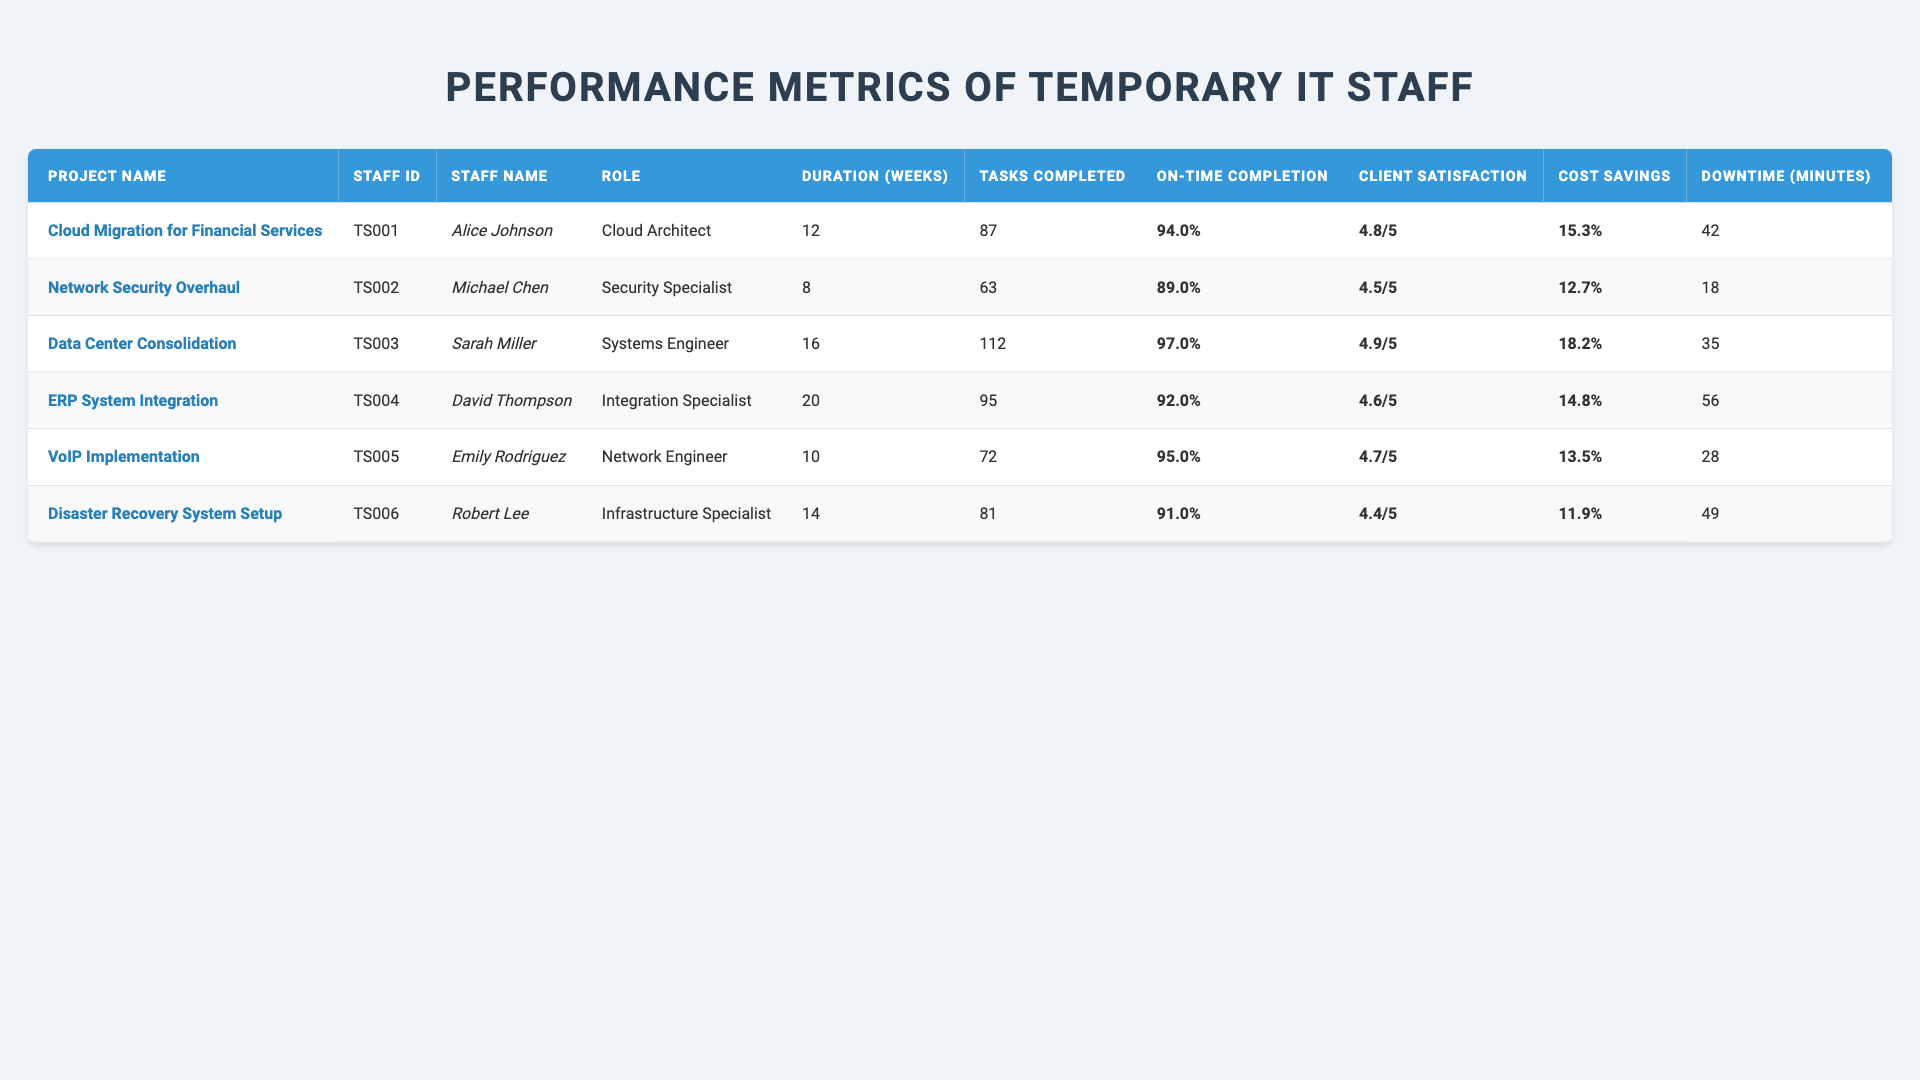What is the project duration for the "Data Center Consolidation"? The table shows that the project duration for "Data Center Consolidation" is 16 weeks.
Answer: 16 weeks Who completed the most tasks? The table indicates that Sarah Miller from the project "Data Center Consolidation" completed the most tasks with a total of 112.
Answer: Sarah Miller What is the on-time completion rate of the "VoIP Implementation"? The table specifies that the on-time completion rate for the "VoIP Implementation" is 95%.
Answer: 95% Which staff member had the highest client satisfaction score? According to the table, Sarah Miller scored the highest client satisfaction at 4.9.
Answer: Sarah Miller How many minutes of downtime did Robert Lee's project incur? The table states that Robert Lee’s project, "Disaster Recovery System Setup," incurred 49 minutes of downtime.
Answer: 49 minutes What is the average cost savings percentage of all projects? The cost savings percentages are: 15.3, 12.7, 18.2, 14.8, 13.5, and 11.9. The sum of these values is 86.4. There are 6 projects, so the average is 86.4/6 = 14.4.
Answer: 14.4% Is there any project where the client satisfaction score was below 4.5? By examining the table, the client satisfaction score for "Disaster Recovery System Setup" is 4.4, which is below 4.5.
Answer: Yes What is the total number of tasks completed by all temporary staff? The total tasks completed are: 87, 63, 112, 95, 72, and 81. Adding these gives 510 (87+63+112+95+72+81=510).
Answer: 510 tasks What is the difference in on-time completion rate between the "Network Security Overhaul" and the "Cloud Migration for Financial Services"? The on-time completion rate for "Network Security Overhaul" is 89%, and for "Cloud Migration for Financial Services" it is 94%. The difference is 94 - 89 = 5.
Answer: 5% Who had the least amount of downtime, and what was it? Looking at the table, "Network Security Overhaul" led by Michael Chen had the least downtime at 18 minutes.
Answer: Michael Chen, 18 minutes What is the total project duration of all projects combined? The project durations are: 12, 8, 16, 20, 10, and 14 weeks. The total duration sums to 12 + 8 + 16 + 20 + 10 + 14 = 80 weeks.
Answer: 80 weeks 